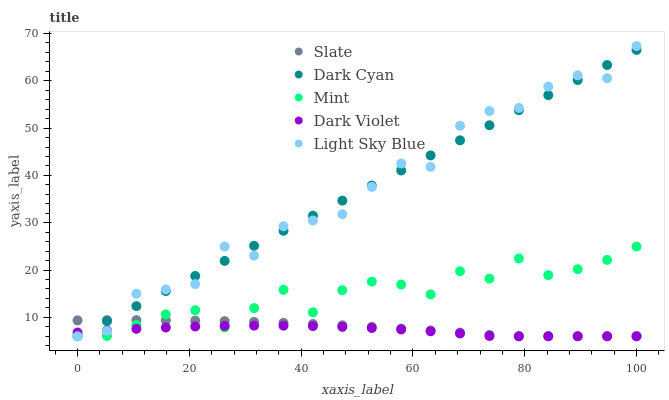Does Dark Violet have the minimum area under the curve?
Answer yes or no. Yes. Does Light Sky Blue have the maximum area under the curve?
Answer yes or no. Yes. Does Slate have the minimum area under the curve?
Answer yes or no. No. Does Slate have the maximum area under the curve?
Answer yes or no. No. Is Dark Cyan the smoothest?
Answer yes or no. Yes. Is Light Sky Blue the roughest?
Answer yes or no. Yes. Is Slate the smoothest?
Answer yes or no. No. Is Slate the roughest?
Answer yes or no. No. Does Dark Cyan have the lowest value?
Answer yes or no. Yes. Does Light Sky Blue have the highest value?
Answer yes or no. Yes. Does Slate have the highest value?
Answer yes or no. No. Does Light Sky Blue intersect Mint?
Answer yes or no. Yes. Is Light Sky Blue less than Mint?
Answer yes or no. No. Is Light Sky Blue greater than Mint?
Answer yes or no. No. 